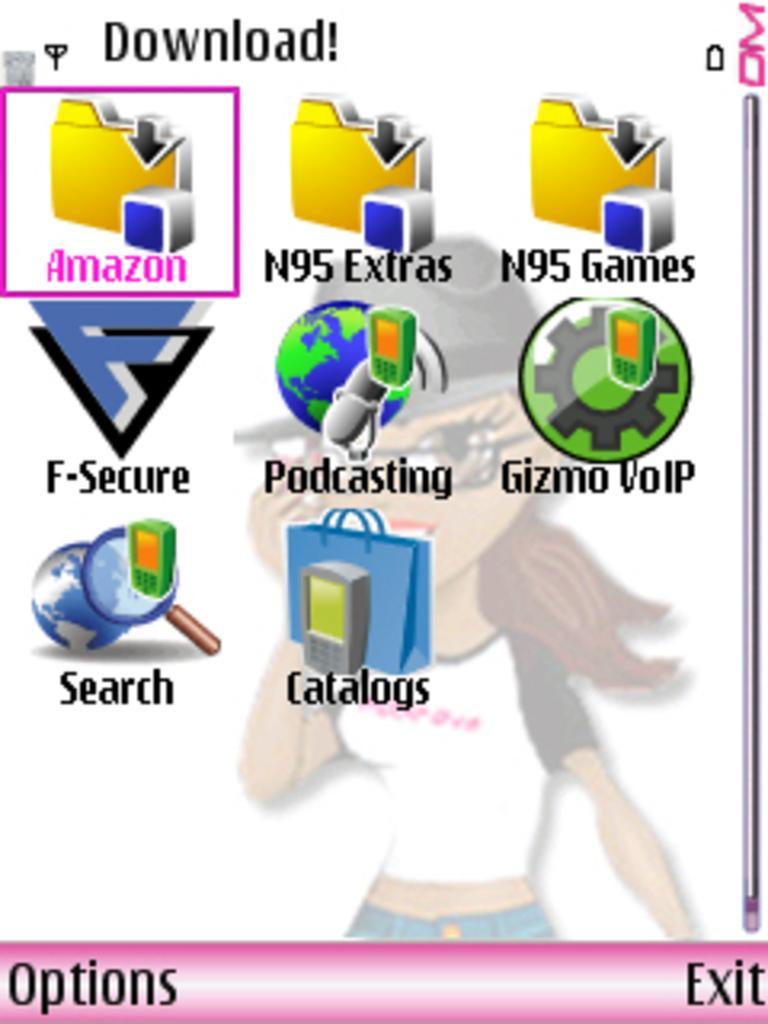Could you give a brief overview of what you see in this image? In this image I can see few logos in different color. Background I can see a cartoon girl and it is in white color. 